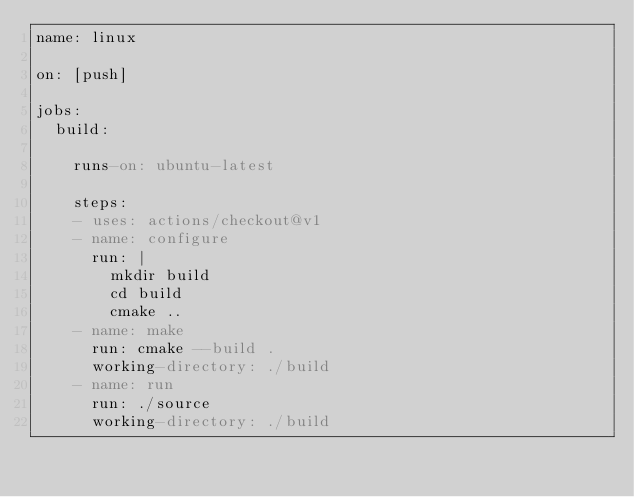<code> <loc_0><loc_0><loc_500><loc_500><_YAML_>name: linux

on: [push]

jobs:
  build:

    runs-on: ubuntu-latest
    
    steps:
    - uses: actions/checkout@v1
    - name: configure
      run: |
        mkdir build
        cd build
        cmake ..
    - name: make
      run: cmake --build .
      working-directory: ./build
    - name: run
      run: ./source
      working-directory: ./build

</code> 